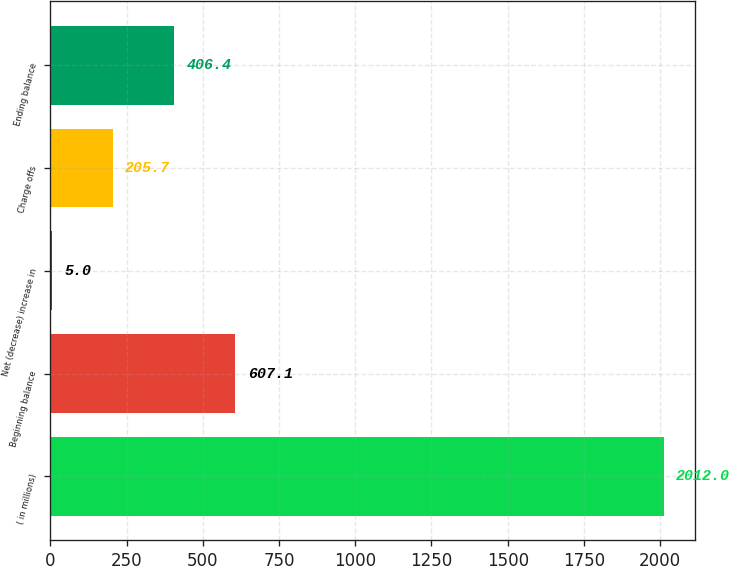<chart> <loc_0><loc_0><loc_500><loc_500><bar_chart><fcel>( in millions)<fcel>Beginning balance<fcel>Net (decrease) increase in<fcel>Charge offs<fcel>Ending balance<nl><fcel>2012<fcel>607.1<fcel>5<fcel>205.7<fcel>406.4<nl></chart> 